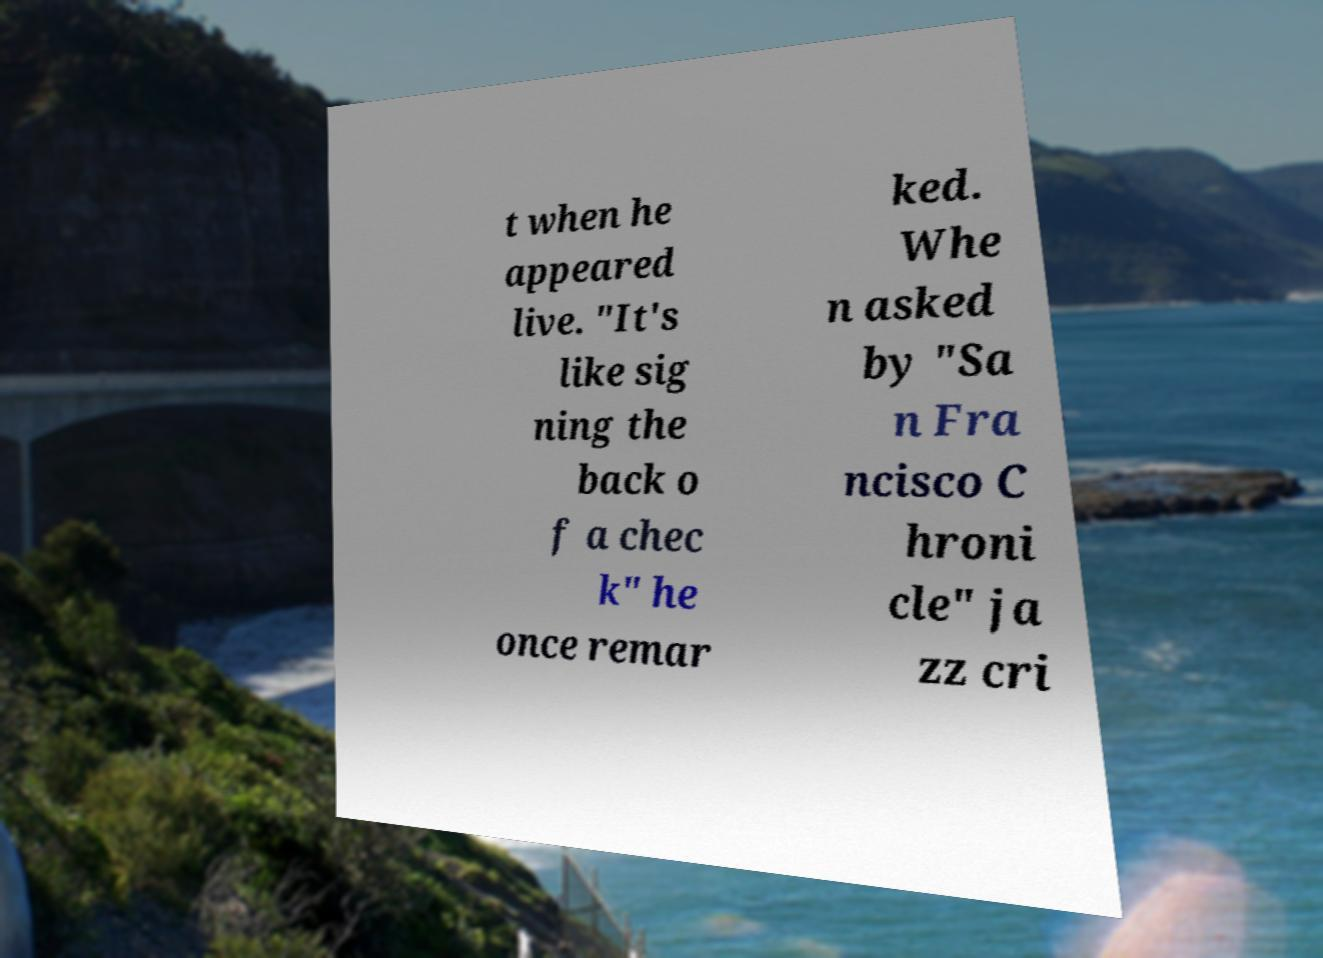Could you assist in decoding the text presented in this image and type it out clearly? t when he appeared live. "It's like sig ning the back o f a chec k" he once remar ked. Whe n asked by "Sa n Fra ncisco C hroni cle" ja zz cri 